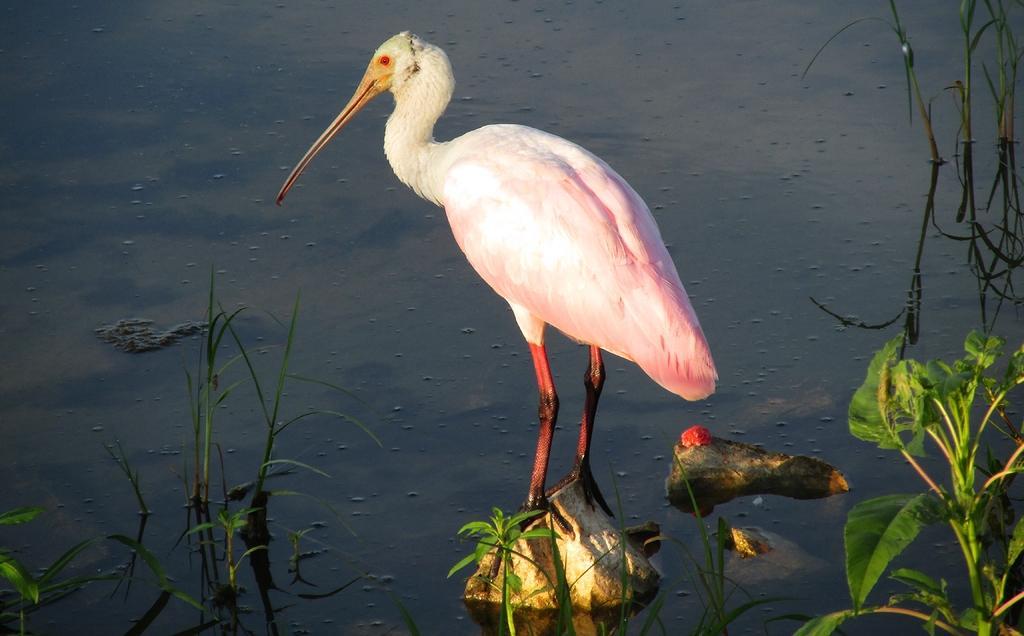Can you describe this image briefly? In this picture there is a crane standing on the stone and there are plants and stones. At the bottom there is water. 